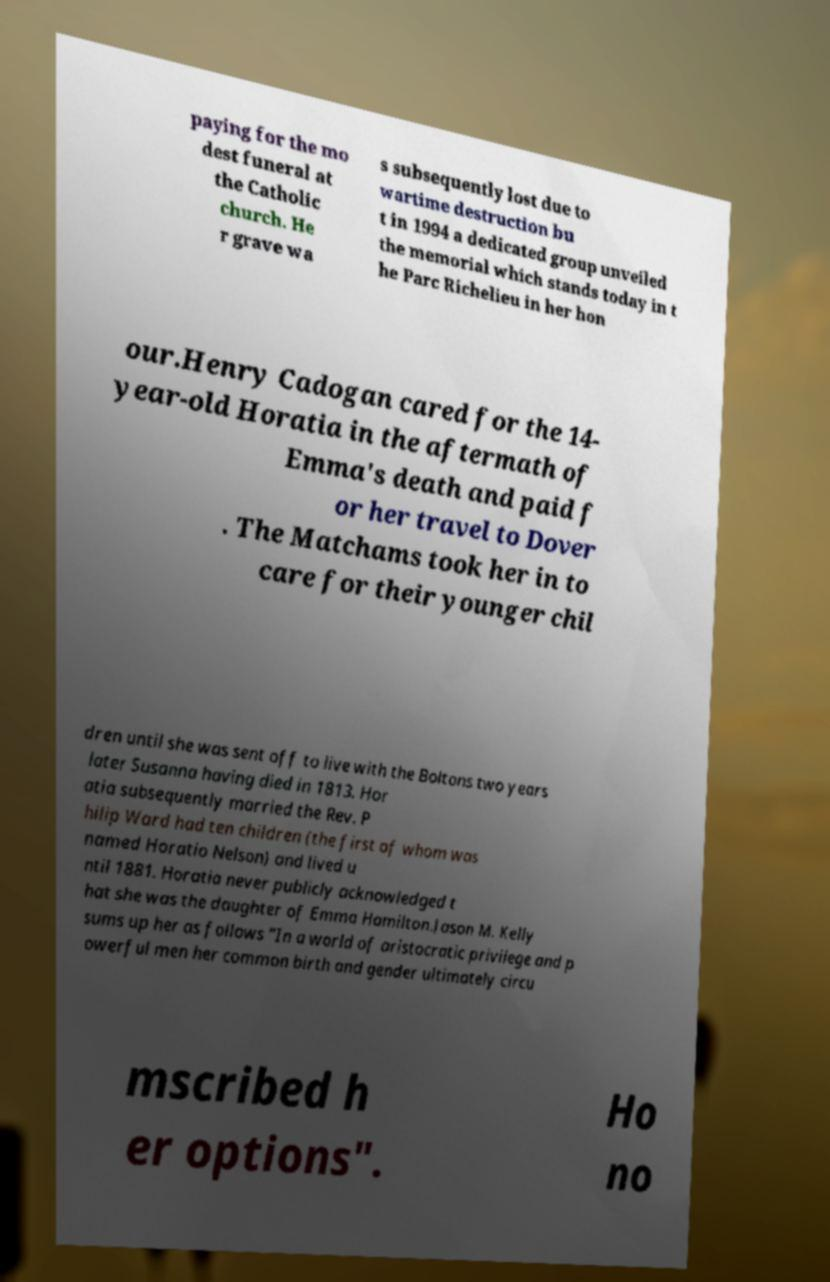Can you accurately transcribe the text from the provided image for me? paying for the mo dest funeral at the Catholic church. He r grave wa s subsequently lost due to wartime destruction bu t in 1994 a dedicated group unveiled the memorial which stands today in t he Parc Richelieu in her hon our.Henry Cadogan cared for the 14- year-old Horatia in the aftermath of Emma's death and paid f or her travel to Dover . The Matchams took her in to care for their younger chil dren until she was sent off to live with the Boltons two years later Susanna having died in 1813. Hor atia subsequently married the Rev. P hilip Ward had ten children (the first of whom was named Horatio Nelson) and lived u ntil 1881. Horatia never publicly acknowledged t hat she was the daughter of Emma Hamilton.Jason M. Kelly sums up her as follows "In a world of aristocratic privilege and p owerful men her common birth and gender ultimately circu mscribed h er options". Ho no 